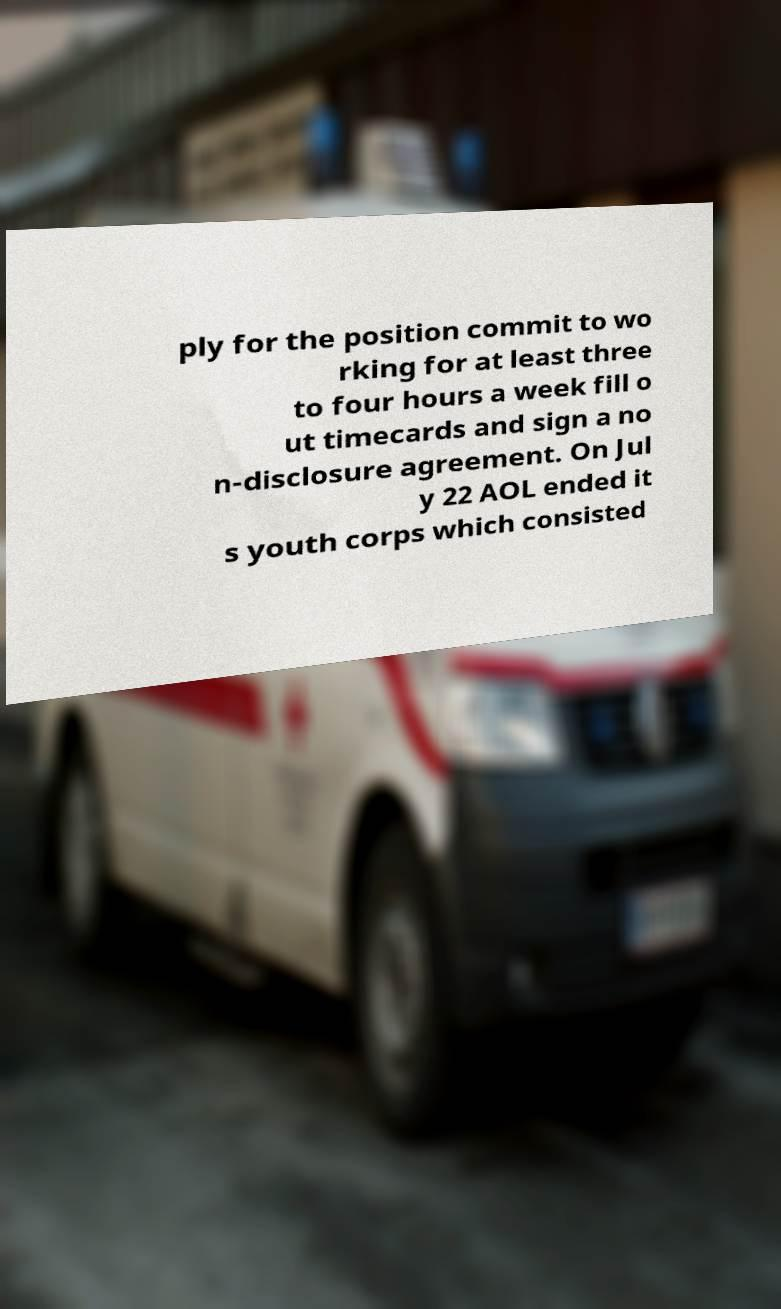Could you assist in decoding the text presented in this image and type it out clearly? ply for the position commit to wo rking for at least three to four hours a week fill o ut timecards and sign a no n-disclosure agreement. On Jul y 22 AOL ended it s youth corps which consisted 